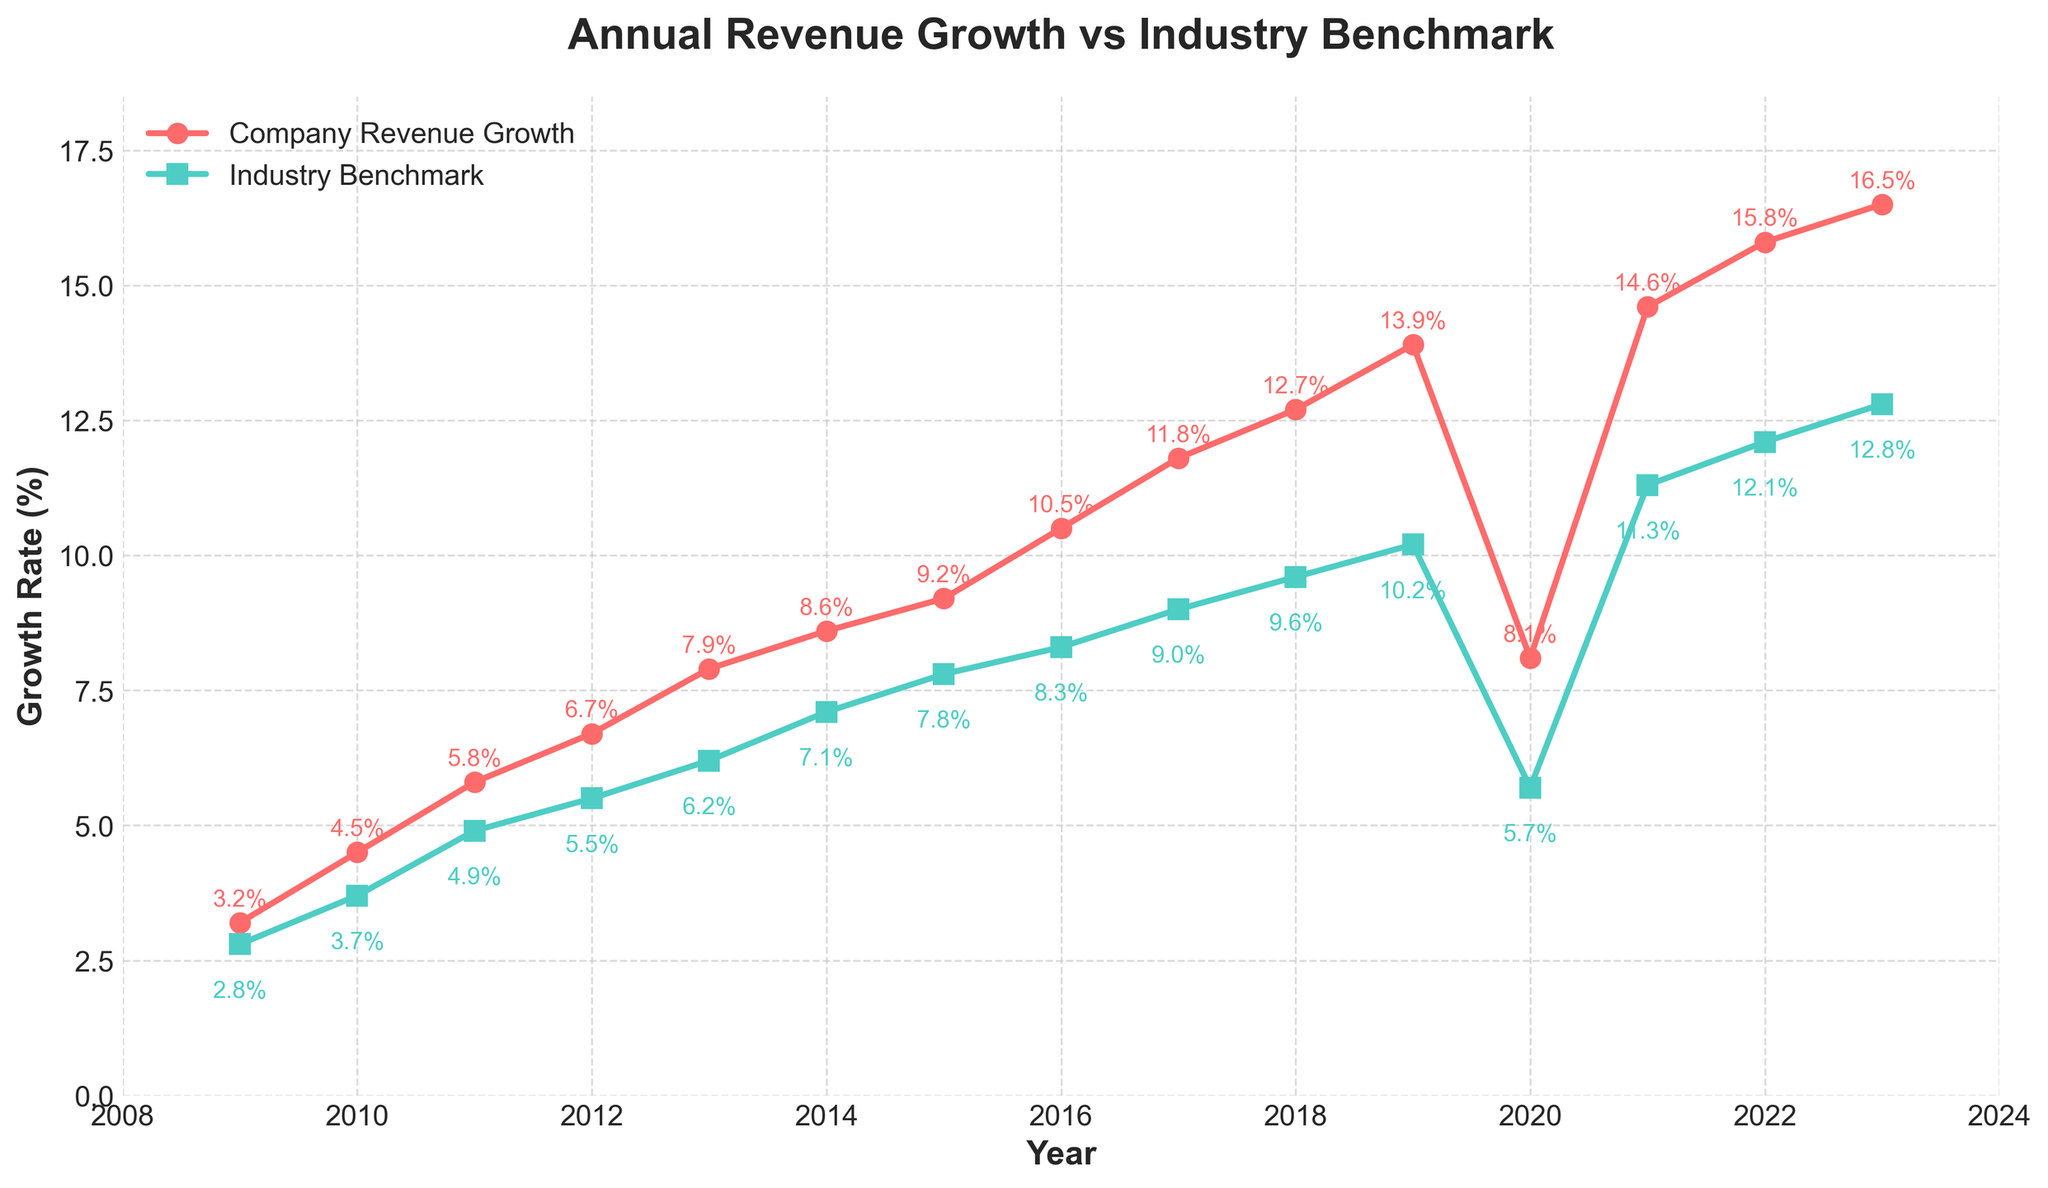What's the average revenue growth of the company over the last 15 years? To find the average revenue growth of the company over the last 15 years, sum up all the annual growth rates and then divide by the number of years. The sum is (3.2 + 4.5 + 5.8 + 6.7 + 7.9 + 8.6 + 9.2 + 10.5 + 11.8 + 12.7 + 13.9 + 8.1 + 14.6 + 15.8 + 16.5) = 150.8. Dividing by 15 gives 150.8 / 15 = 10.05.
Answer: 10.05 In which year does the company revenue growth significantly drop compared to the previous year? Looking at the line chart, we notice a sharp drop in the company revenue growth between 2019 and 2020, going from 13.9% in 2019 to 8.1% in 2020.
Answer: 2020 How many times did the company revenue growth exceed the industry benchmark over the last 15 years? Observing the plot, the company’s revenue growth exceeds the industry benchmark in all 15 years.
Answer: 15 By how much did the company revenue growth exceed the industry benchmark on average per year? First, calculate the differences for each year: (3.2-2.8) + (4.5-3.7) + (5.8-4.9) + (6.7-5.5) + (7.9-6.2) + (8.6-7.1) + (9.2-7.8) + (10.5-8.3) + (11.8-9.0) + (12.7-9.6) + (13.9-10.2) + (8.1-5.7) + (14.6-11.3) + (15.8-12.1) + (16.5-12.8) = 21.8. Average = 21.8 / 15 = 1.45.
Answer: 1.45 Which year saw the highest company revenue growth and what was its value? The highest company revenue growth occurred in 2023, with a value of 16.5%.
Answer: 2023, 16.5% In which year is the gap between the company revenue growth and the industry benchmark the smallest? By inspecting the differences visually, the smallest gap seems to be in the year 2010, where the company growth is 4.5% and the industry benchmark is 3.7%, a gap of 0.8%.
Answer: 2010 How does the company’s revenue growth trend compare to the industry benchmark from 2017 to 2023? From 2017 to 2023, both the company's revenue growth and the industry benchmark show an upward trend. However, the company's growth is consistently and increasingly higher than the industry benchmark during these years.
Answer: Both upward, company higher Which color represents the company's revenue growth line on the chart? The company's revenue growth line is represented by a red color.
Answer: Red 